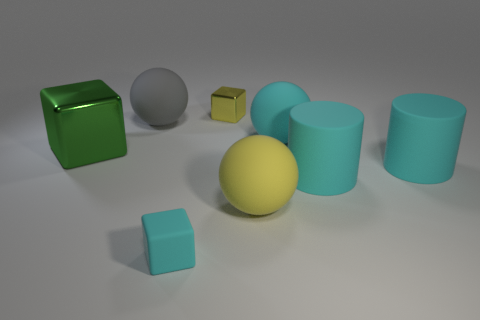Are there an equal number of tiny yellow things behind the big cyan matte ball and small cyan cubes?
Your answer should be very brief. Yes. The block that is the same size as the gray object is what color?
Your answer should be very brief. Green. Is there a tiny gray shiny thing of the same shape as the big yellow object?
Your answer should be very brief. No. What material is the large sphere that is to the left of the small yellow metallic object behind the cyan rubber thing left of the small yellow thing?
Your response must be concise. Rubber. How many other things are the same size as the green block?
Offer a very short reply. 5. The matte block has what color?
Make the answer very short. Cyan. How many metal objects are big yellow balls or small cyan objects?
Provide a short and direct response. 0. Is there any other thing that is the same material as the gray sphere?
Offer a very short reply. Yes. There is a yellow object in front of the metallic object on the left side of the tiny thing that is behind the gray ball; what is its size?
Ensure brevity in your answer.  Large. There is a ball that is both on the left side of the cyan ball and right of the big gray rubber sphere; how big is it?
Keep it short and to the point. Large. 